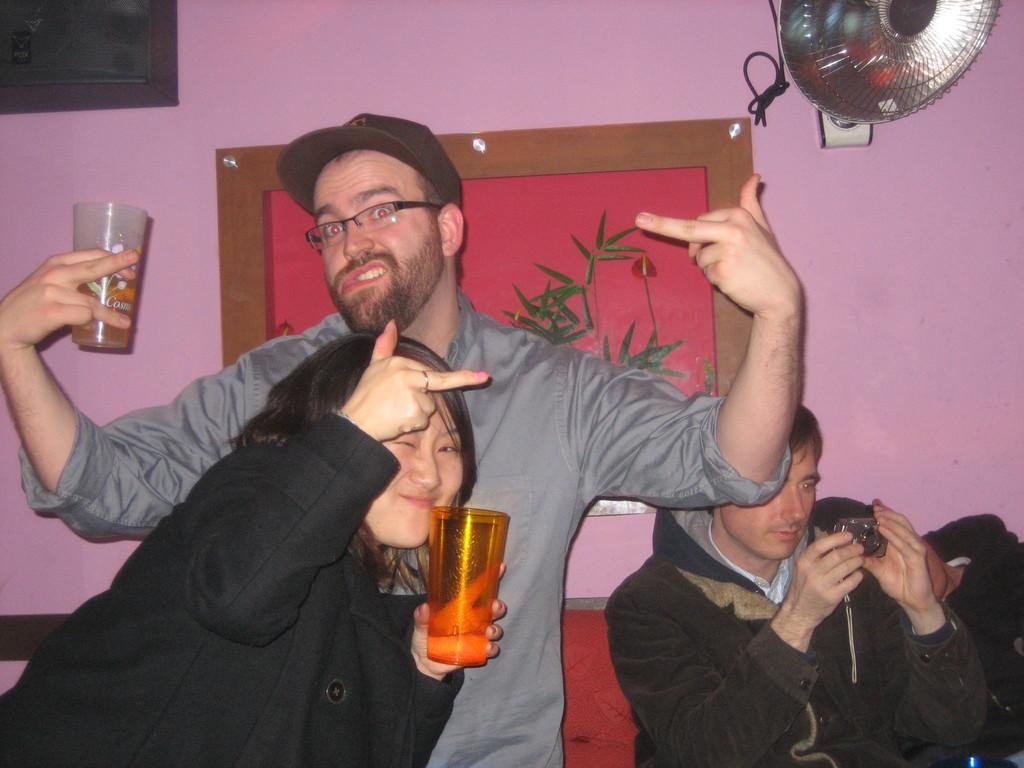In one or two sentences, can you explain what this image depicts? Here a man is standing in the middle and just chilling with a wine. He wears a spectacles and cap and a woman is is wearing a black color coat and a glass in her and she is showing some symbols with her hand there is a wall. 